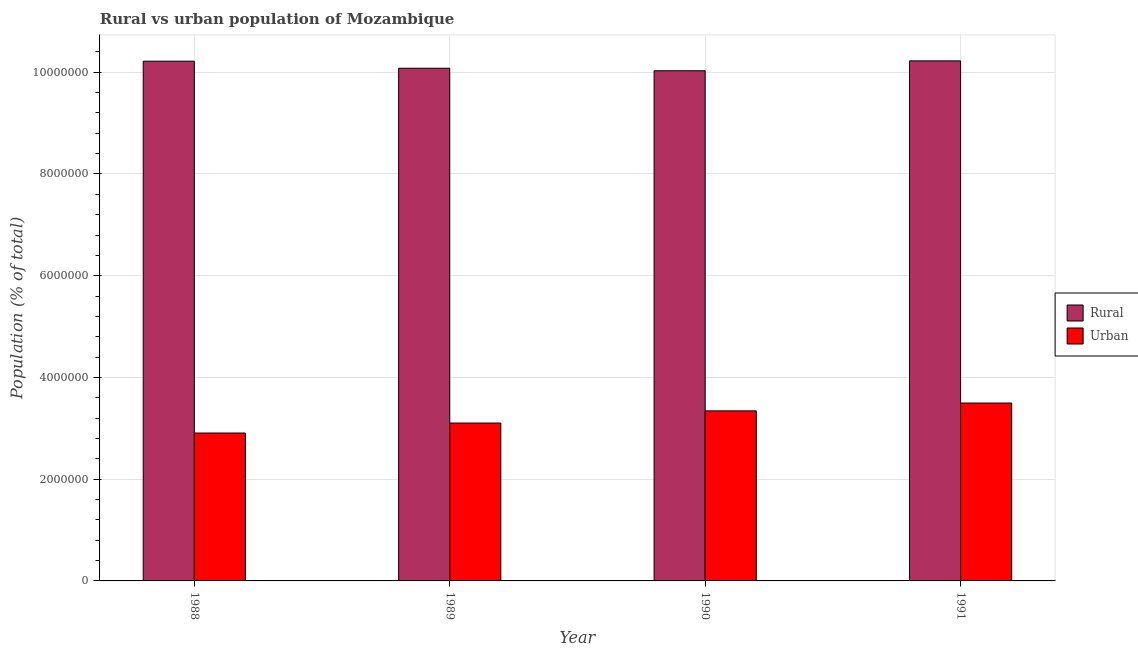How many different coloured bars are there?
Your answer should be compact. 2. How many bars are there on the 1st tick from the right?
Offer a terse response. 2. In how many cases, is the number of bars for a given year not equal to the number of legend labels?
Your answer should be very brief. 0. What is the rural population density in 1988?
Provide a succinct answer. 1.02e+07. Across all years, what is the maximum rural population density?
Make the answer very short. 1.02e+07. Across all years, what is the minimum rural population density?
Keep it short and to the point. 1.00e+07. In which year was the urban population density maximum?
Your response must be concise. 1991. What is the total urban population density in the graph?
Offer a terse response. 1.29e+07. What is the difference between the urban population density in 1989 and that in 1991?
Your answer should be compact. -3.93e+05. What is the difference between the urban population density in 1990 and the rural population density in 1989?
Your answer should be very brief. 2.39e+05. What is the average urban population density per year?
Give a very brief answer. 3.21e+06. In the year 1989, what is the difference between the urban population density and rural population density?
Your answer should be compact. 0. What is the ratio of the urban population density in 1990 to that in 1991?
Your answer should be compact. 0.96. Is the urban population density in 1990 less than that in 1991?
Provide a short and direct response. Yes. What is the difference between the highest and the second highest rural population density?
Give a very brief answer. 6081. What is the difference between the highest and the lowest urban population density?
Ensure brevity in your answer.  5.89e+05. Is the sum of the rural population density in 1988 and 1989 greater than the maximum urban population density across all years?
Provide a short and direct response. Yes. What does the 1st bar from the left in 1988 represents?
Make the answer very short. Rural. What does the 2nd bar from the right in 1989 represents?
Make the answer very short. Rural. How many bars are there?
Ensure brevity in your answer.  8. Are all the bars in the graph horizontal?
Ensure brevity in your answer.  No. Are the values on the major ticks of Y-axis written in scientific E-notation?
Give a very brief answer. No. Does the graph contain any zero values?
Provide a short and direct response. No. Does the graph contain grids?
Give a very brief answer. Yes. What is the title of the graph?
Ensure brevity in your answer.  Rural vs urban population of Mozambique. What is the label or title of the Y-axis?
Provide a succinct answer. Population (% of total). What is the Population (% of total) of Rural in 1988?
Ensure brevity in your answer.  1.02e+07. What is the Population (% of total) in Urban in 1988?
Offer a very short reply. 2.91e+06. What is the Population (% of total) in Rural in 1989?
Your answer should be compact. 1.01e+07. What is the Population (% of total) of Urban in 1989?
Your response must be concise. 3.10e+06. What is the Population (% of total) in Rural in 1990?
Give a very brief answer. 1.00e+07. What is the Population (% of total) in Urban in 1990?
Give a very brief answer. 3.34e+06. What is the Population (% of total) in Rural in 1991?
Keep it short and to the point. 1.02e+07. What is the Population (% of total) in Urban in 1991?
Give a very brief answer. 3.50e+06. Across all years, what is the maximum Population (% of total) of Rural?
Keep it short and to the point. 1.02e+07. Across all years, what is the maximum Population (% of total) of Urban?
Give a very brief answer. 3.50e+06. Across all years, what is the minimum Population (% of total) in Rural?
Your answer should be compact. 1.00e+07. Across all years, what is the minimum Population (% of total) in Urban?
Provide a succinct answer. 2.91e+06. What is the total Population (% of total) of Rural in the graph?
Your answer should be very brief. 4.05e+07. What is the total Population (% of total) in Urban in the graph?
Ensure brevity in your answer.  1.29e+07. What is the difference between the Population (% of total) of Rural in 1988 and that in 1989?
Offer a very short reply. 1.39e+05. What is the difference between the Population (% of total) of Urban in 1988 and that in 1989?
Provide a short and direct response. -1.96e+05. What is the difference between the Population (% of total) in Rural in 1988 and that in 1990?
Give a very brief answer. 1.88e+05. What is the difference between the Population (% of total) in Urban in 1988 and that in 1990?
Ensure brevity in your answer.  -4.36e+05. What is the difference between the Population (% of total) in Rural in 1988 and that in 1991?
Offer a very short reply. -6081. What is the difference between the Population (% of total) in Urban in 1988 and that in 1991?
Offer a terse response. -5.89e+05. What is the difference between the Population (% of total) of Rural in 1989 and that in 1990?
Offer a terse response. 4.93e+04. What is the difference between the Population (% of total) in Urban in 1989 and that in 1990?
Keep it short and to the point. -2.39e+05. What is the difference between the Population (% of total) of Rural in 1989 and that in 1991?
Your answer should be very brief. -1.45e+05. What is the difference between the Population (% of total) of Urban in 1989 and that in 1991?
Your answer should be very brief. -3.93e+05. What is the difference between the Population (% of total) in Rural in 1990 and that in 1991?
Offer a terse response. -1.94e+05. What is the difference between the Population (% of total) of Urban in 1990 and that in 1991?
Provide a succinct answer. -1.54e+05. What is the difference between the Population (% of total) in Rural in 1988 and the Population (% of total) in Urban in 1989?
Keep it short and to the point. 7.11e+06. What is the difference between the Population (% of total) of Rural in 1988 and the Population (% of total) of Urban in 1990?
Offer a terse response. 6.87e+06. What is the difference between the Population (% of total) in Rural in 1988 and the Population (% of total) in Urban in 1991?
Your answer should be compact. 6.72e+06. What is the difference between the Population (% of total) in Rural in 1989 and the Population (% of total) in Urban in 1990?
Offer a terse response. 6.74e+06. What is the difference between the Population (% of total) of Rural in 1989 and the Population (% of total) of Urban in 1991?
Offer a terse response. 6.58e+06. What is the difference between the Population (% of total) of Rural in 1990 and the Population (% of total) of Urban in 1991?
Make the answer very short. 6.53e+06. What is the average Population (% of total) of Rural per year?
Your response must be concise. 1.01e+07. What is the average Population (% of total) in Urban per year?
Provide a succinct answer. 3.21e+06. In the year 1988, what is the difference between the Population (% of total) in Rural and Population (% of total) in Urban?
Make the answer very short. 7.31e+06. In the year 1989, what is the difference between the Population (% of total) of Rural and Population (% of total) of Urban?
Provide a short and direct response. 6.97e+06. In the year 1990, what is the difference between the Population (% of total) of Rural and Population (% of total) of Urban?
Offer a terse response. 6.69e+06. In the year 1991, what is the difference between the Population (% of total) in Rural and Population (% of total) in Urban?
Your answer should be very brief. 6.73e+06. What is the ratio of the Population (% of total) in Rural in 1988 to that in 1989?
Keep it short and to the point. 1.01. What is the ratio of the Population (% of total) of Urban in 1988 to that in 1989?
Offer a terse response. 0.94. What is the ratio of the Population (% of total) of Rural in 1988 to that in 1990?
Provide a short and direct response. 1.02. What is the ratio of the Population (% of total) in Urban in 1988 to that in 1990?
Your answer should be very brief. 0.87. What is the ratio of the Population (% of total) in Rural in 1988 to that in 1991?
Offer a very short reply. 1. What is the ratio of the Population (% of total) in Urban in 1988 to that in 1991?
Offer a very short reply. 0.83. What is the ratio of the Population (% of total) of Urban in 1989 to that in 1990?
Provide a short and direct response. 0.93. What is the ratio of the Population (% of total) of Rural in 1989 to that in 1991?
Make the answer very short. 0.99. What is the ratio of the Population (% of total) of Urban in 1989 to that in 1991?
Make the answer very short. 0.89. What is the ratio of the Population (% of total) in Rural in 1990 to that in 1991?
Offer a very short reply. 0.98. What is the ratio of the Population (% of total) in Urban in 1990 to that in 1991?
Ensure brevity in your answer.  0.96. What is the difference between the highest and the second highest Population (% of total) in Rural?
Keep it short and to the point. 6081. What is the difference between the highest and the second highest Population (% of total) of Urban?
Keep it short and to the point. 1.54e+05. What is the difference between the highest and the lowest Population (% of total) in Rural?
Your response must be concise. 1.94e+05. What is the difference between the highest and the lowest Population (% of total) of Urban?
Keep it short and to the point. 5.89e+05. 